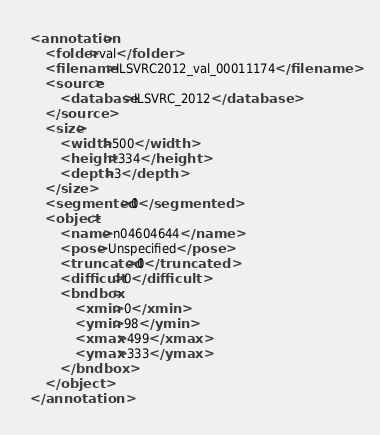<code> <loc_0><loc_0><loc_500><loc_500><_XML_><annotation>
	<folder>val</folder>
	<filename>ILSVRC2012_val_00011174</filename>
	<source>
		<database>ILSVRC_2012</database>
	</source>
	<size>
		<width>500</width>
		<height>334</height>
		<depth>3</depth>
	</size>
	<segmented>0</segmented>
	<object>
		<name>n04604644</name>
		<pose>Unspecified</pose>
		<truncated>0</truncated>
		<difficult>0</difficult>
		<bndbox>
			<xmin>0</xmin>
			<ymin>98</ymin>
			<xmax>499</xmax>
			<ymax>333</ymax>
		</bndbox>
	</object>
</annotation></code> 